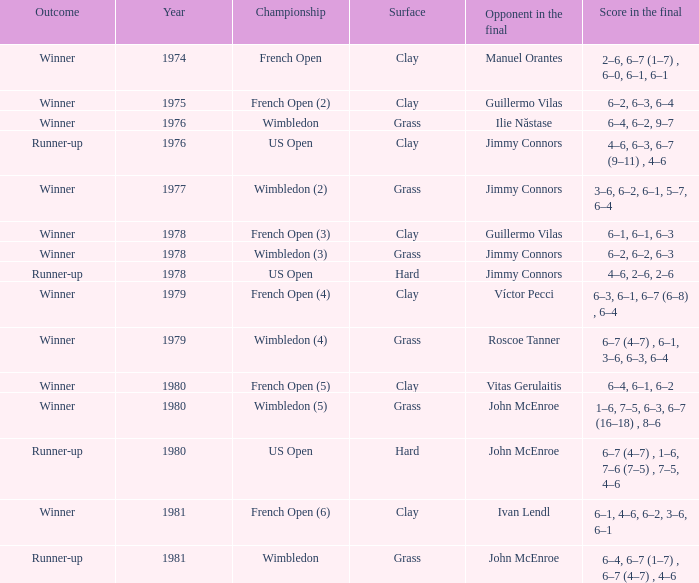What is every year where opponent in the final is John Mcenroe at Wimbledon? 1981.0. 